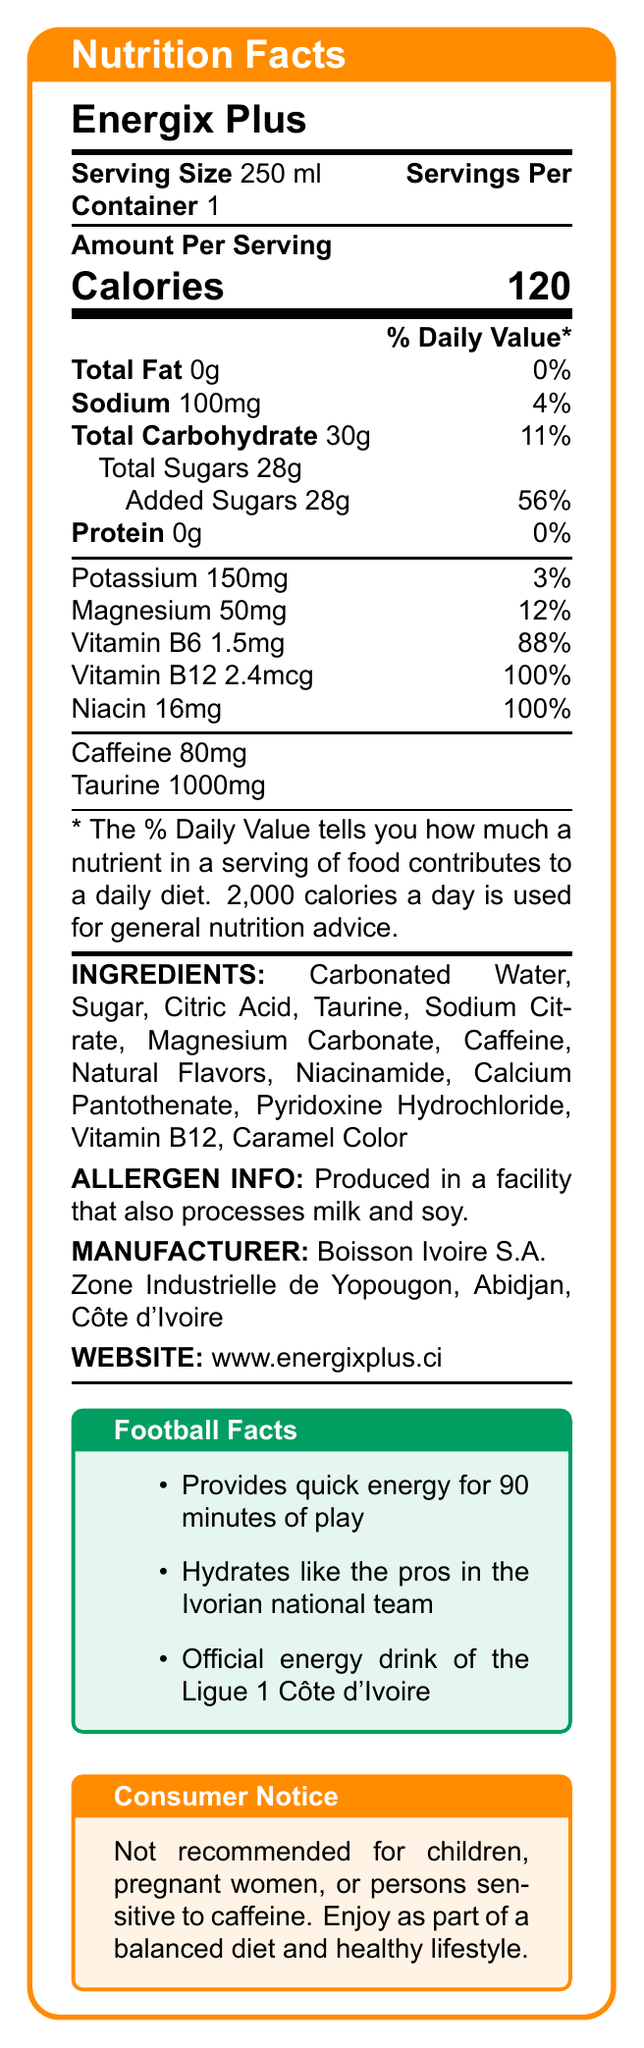what is the serving size of Energix Plus? The document lists "Serving Size" as 250 ml.
Answer: 250 ml how many calories are in one serving? The document indicates that there are 120 calories per serving.
Answer: 120 what is the total carbohydrate content? The "Total Carbohydrate" section states that there are 30g of carbohydrates in each serving.
Answer: 30g how much sugar is added to Energix Plus? Under "Total Sugars," it mentions that the "Added Sugars" amount is 28g.
Answer: 28g what is the amount of caffeine in Energix Plus? The document lists "Caffeine" as 80mg.
Answer: 80mg how much Vitamin B12 is in one serving? The document states that each serving contains 2.4 mcg of Vitamin B12.
Answer: 2.4 mcg which ingredient is present in the highest quantity? A. Taurine B. Caffeine C. Sugar D. Magnesium The ingredient list is ordered by quantity, and “Sugar” appears early on the list, indicating it's present in high quantity.
Answer: C. Sugar what is the daily value percentage for magnesium? The document lists "Magnesium" as contributing 12% to the daily value.
Answer: 12% where is Energix Plus manufactured? A. Abidjan B. Bouaké C. Yamoussoukro The manufacturer's address is listed as "Zone Industrielle de Yopougon, Abidjan, Côte d'Ivoire."
Answer: A. Abidjan is Energix Plus recommended for children? The consumer notice states that the drink is "Not recommended for children."
Answer: No can Energix Plus provide energy for a full football match? One of the football facts states that the drink provides quick energy for 90 minutes of play, which is the duration of a football match.
Answer: Yes summarize the main purpose of Energix Plus according to the document. The document highlights its nutritional facts, ingredients, and special features that make it suitable for sustaining energy and hydration during physical activity.
Answer: Energix Plus is an energy drink designed to provide quick energy and hydration, enhanced with electrolytes and vitamins, suitable for professional and amateur athletes, particularly those playing football. what other football detail is mentioned about Energix Plus? The Football Facts section mentions that Energix Plus is the official energy drink of the Ligue 1 Côte d'Ivoire.
Answer: It is the official energy drink of the Ligue 1 Côte d'Ivoire. how many servings per container are there? The document clearly lists “Servings Per Container” as 1.
Answer: 1 is the daily value percentage provided for taurine? The document does not provide a daily value percentage for taurine, only the amount (1000mg).
Answer: No which natural flavors are used in Energix Plus? The document lists "Natural Flavors" as an ingredient but does not specify which flavors are used.
Answer: Cannot be determined 